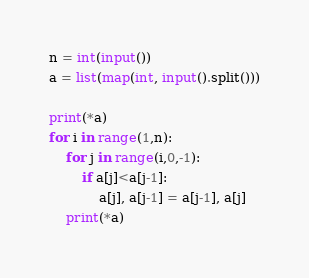Convert code to text. <code><loc_0><loc_0><loc_500><loc_500><_Python_>n = int(input())
a = list(map(int, input().split()))

print(*a)
for i in range(1,n):
    for j in range(i,0,-1):
        if a[j]<a[j-1]:
            a[j], a[j-1] = a[j-1], a[j]
    print(*a)
</code> 